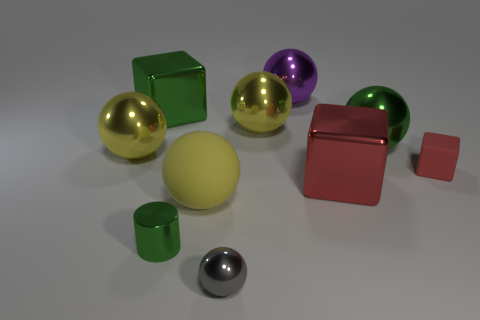Subtract all green cubes. How many cubes are left? 2 Subtract all gray blocks. How many yellow spheres are left? 3 Subtract 4 spheres. How many spheres are left? 2 Subtract all green spheres. How many spheres are left? 5 Subtract all purple spheres. Subtract all cyan cylinders. How many spheres are left? 5 Add 5 cylinders. How many cylinders are left? 6 Add 4 blue metallic spheres. How many blue metallic spheres exist? 4 Subtract 1 purple spheres. How many objects are left? 9 Subtract all cylinders. How many objects are left? 9 Subtract all big gray rubber blocks. Subtract all purple objects. How many objects are left? 9 